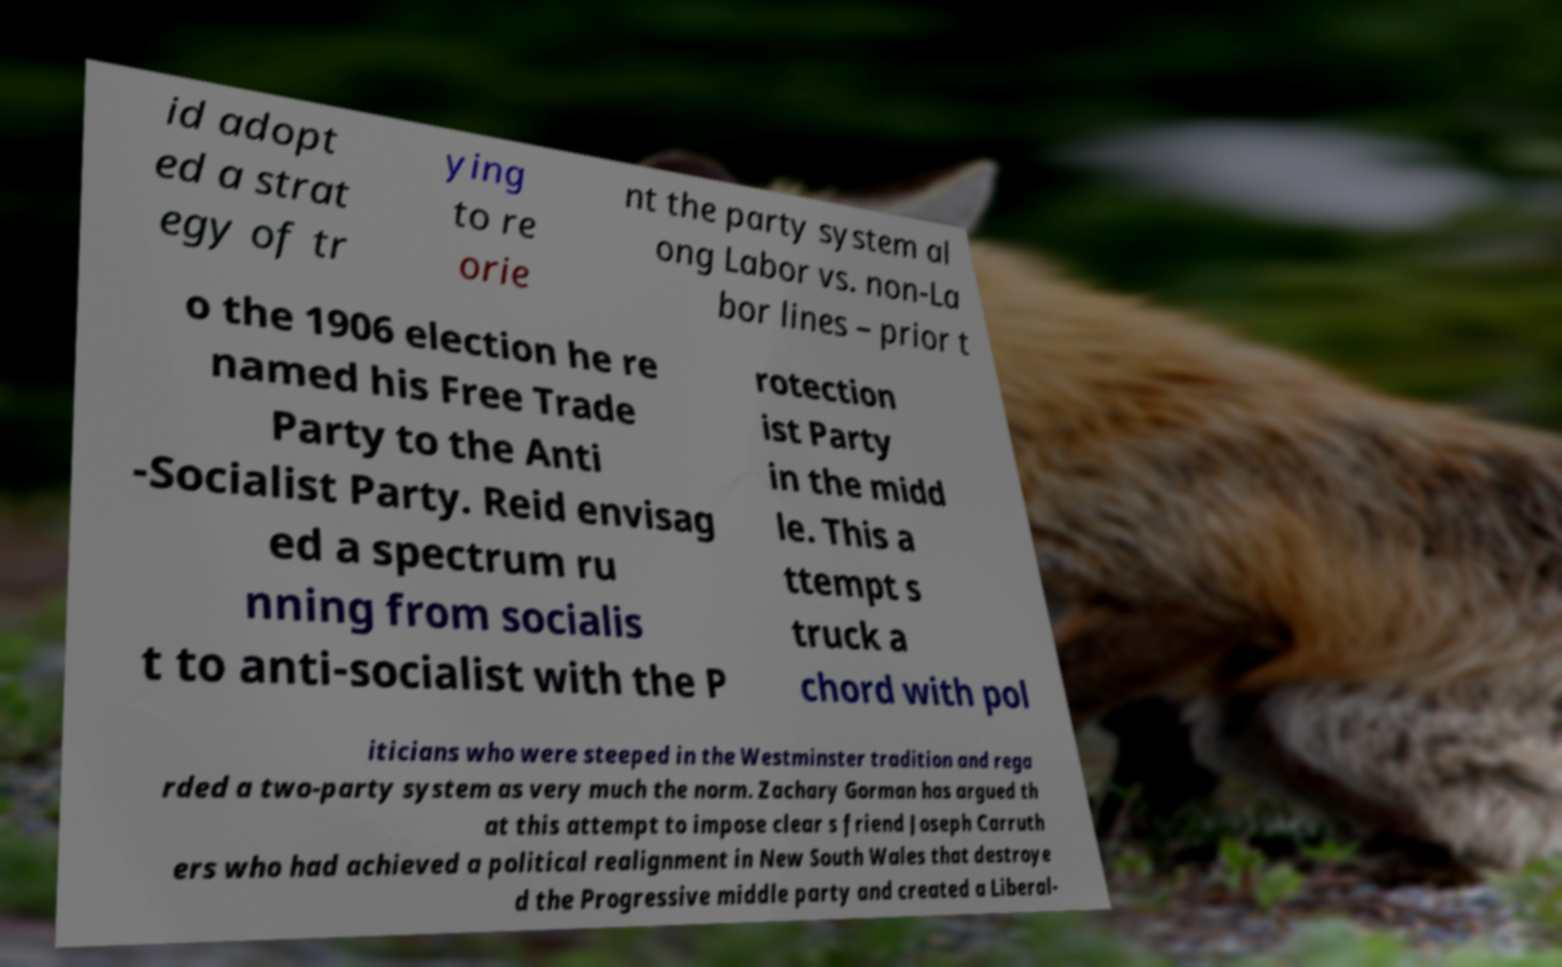Could you extract and type out the text from this image? id adopt ed a strat egy of tr ying to re orie nt the party system al ong Labor vs. non-La bor lines – prior t o the 1906 election he re named his Free Trade Party to the Anti -Socialist Party. Reid envisag ed a spectrum ru nning from socialis t to anti-socialist with the P rotection ist Party in the midd le. This a ttempt s truck a chord with pol iticians who were steeped in the Westminster tradition and rega rded a two-party system as very much the norm. Zachary Gorman has argued th at this attempt to impose clear s friend Joseph Carruth ers who had achieved a political realignment in New South Wales that destroye d the Progressive middle party and created a Liberal- 